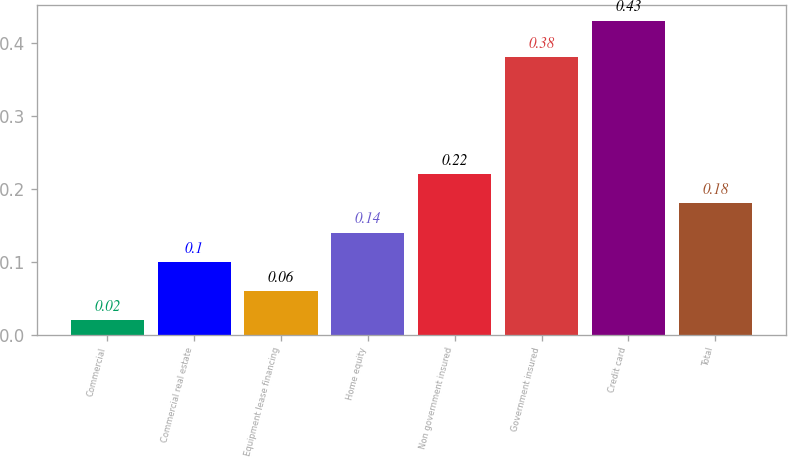Convert chart. <chart><loc_0><loc_0><loc_500><loc_500><bar_chart><fcel>Commercial<fcel>Commercial real estate<fcel>Equipment lease financing<fcel>Home equity<fcel>Non government insured<fcel>Government insured<fcel>Credit card<fcel>Total<nl><fcel>0.02<fcel>0.1<fcel>0.06<fcel>0.14<fcel>0.22<fcel>0.38<fcel>0.43<fcel>0.18<nl></chart> 